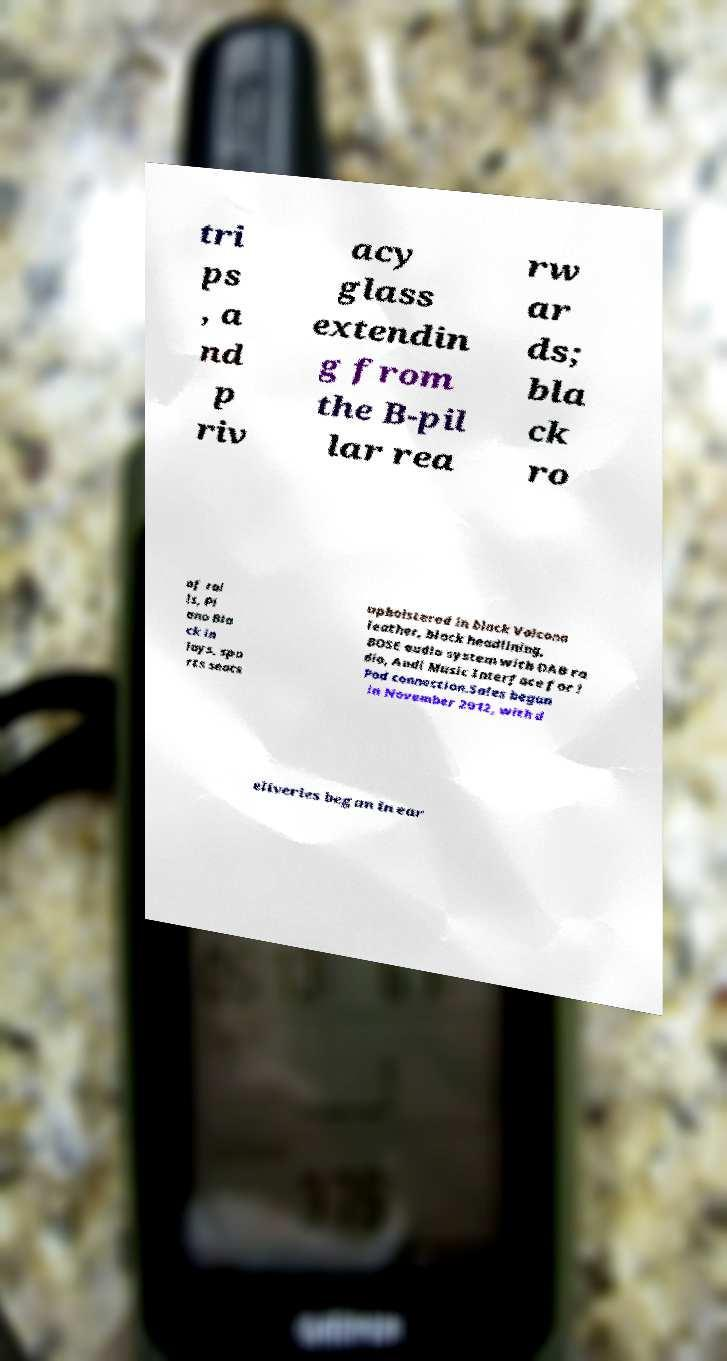What messages or text are displayed in this image? I need them in a readable, typed format. tri ps , a nd p riv acy glass extendin g from the B-pil lar rea rw ar ds; bla ck ro of rai ls, Pi ano Bla ck in lays, spo rts seats upholstered in black Valcona leather, black headlining, BOSE audio system with DAB ra dio, Audi Music Interface for i Pod connection.Sales began in November 2012, with d eliveries began in ear 